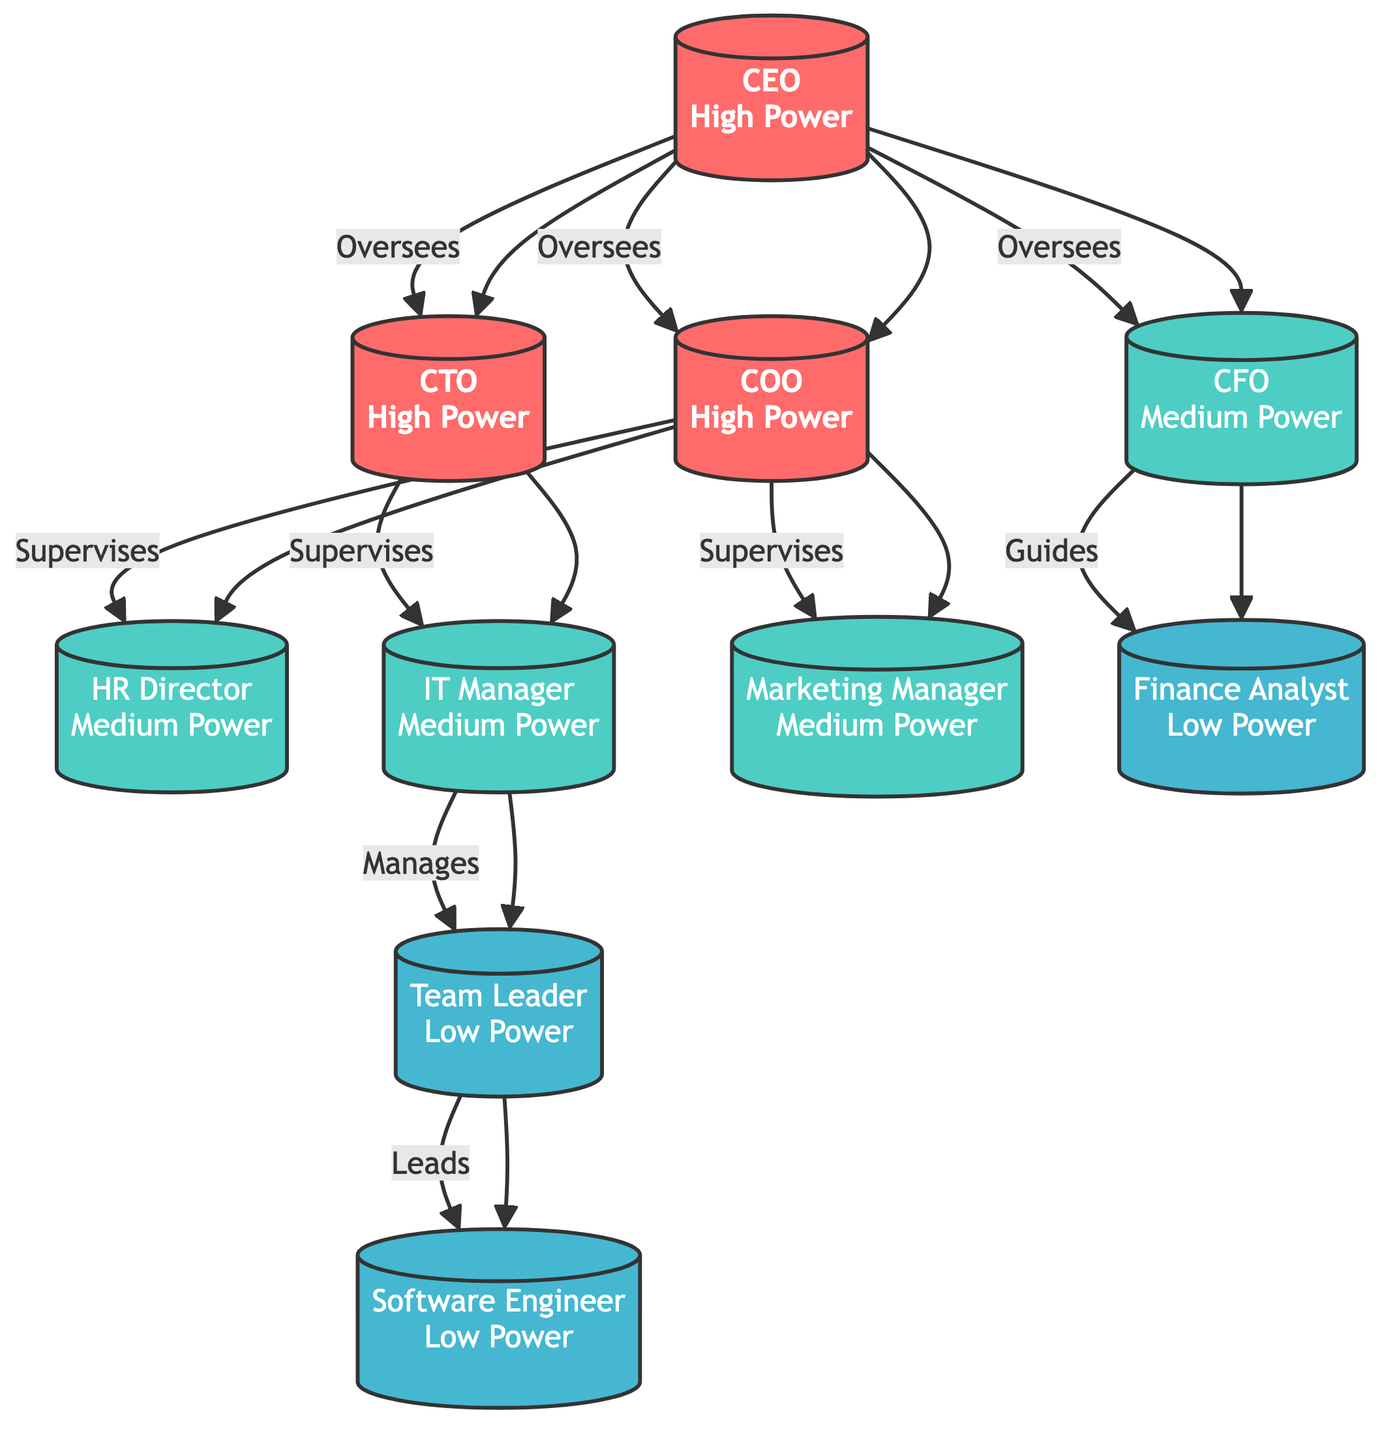What is the highest power role in the organizational chart? The highest power role is the CEO, as indicated at the top of the hierarchy and labeled with "High Power."
Answer: CEO How many roles have medium power? There are four roles labeled as having medium power (CFO, HR Director, IT Manager, Marketing Manager), which can be counted directly from the diagram.
Answer: 4 Which role oversees the IT Manager? The CTO oversees the IT Manager, as shown by the directing arrow from CTO to IT Manager in the diagram.
Answer: CTO How many low power roles are there? The diagram lists three roles with low power (Team Leader, Software Engineer, and Finance Analyst), which can be counted directly from the diagram.
Answer: 3 Who does the HR Director guide? The HR Director guides the Finance Analyst, as indicated by the arrow leading from HR Director to Finance Analyst in the diagram.
Answer: Finance Analyst What is the relationship between the CEO and the COO? The CEO oversees the COO, as indicated by the direct arrow from the CEO to the COO in the diagram.
Answer: Oversees How many connections does the IT Manager have? The IT Manager has one connection (to Team Leader), which can be traced from the arrow pointing to Team Leader.
Answer: 1 Which role supervises the Marketing Manager? The COO supervises the Marketing Manager, as shown by the supervisory arrow from COO to Marketing Manager in the diagram.
Answer: COO What is the role of the Team Leader? The Team Leader leads the Software Engineer, which is directly indicated by the arrow from Team Leader to Software Engineer in the diagram.
Answer: Leads 